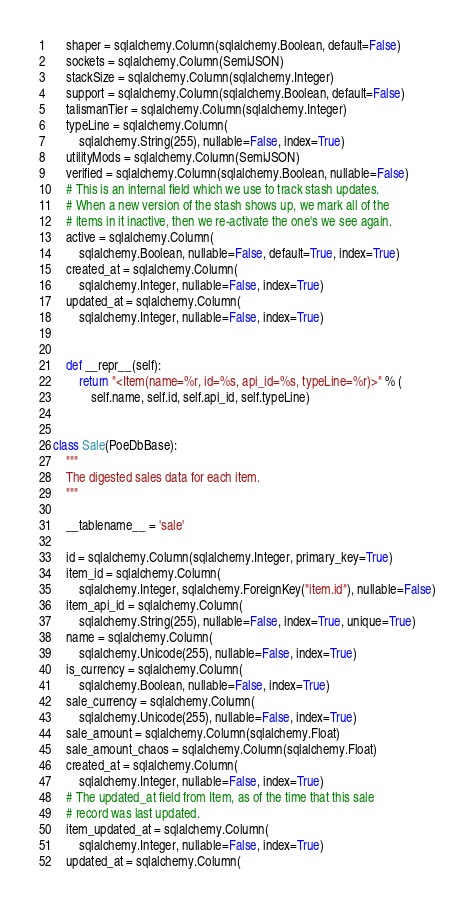Convert code to text. <code><loc_0><loc_0><loc_500><loc_500><_Python_>    shaper = sqlalchemy.Column(sqlalchemy.Boolean, default=False)
    sockets = sqlalchemy.Column(SemiJSON)
    stackSize = sqlalchemy.Column(sqlalchemy.Integer)
    support = sqlalchemy.Column(sqlalchemy.Boolean, default=False)
    talismanTier = sqlalchemy.Column(sqlalchemy.Integer)
    typeLine = sqlalchemy.Column(
        sqlalchemy.String(255), nullable=False, index=True)
    utilityMods = sqlalchemy.Column(SemiJSON)
    verified = sqlalchemy.Column(sqlalchemy.Boolean, nullable=False)
    # This is an internal field which we use to track stash updates.
    # When a new version of the stash shows up, we mark all of the
    # items in it inactive, then we re-activate the one's we see again.
    active = sqlalchemy.Column(
        sqlalchemy.Boolean, nullable=False, default=True, index=True)
    created_at = sqlalchemy.Column(
        sqlalchemy.Integer, nullable=False, index=True)
    updated_at = sqlalchemy.Column(
        sqlalchemy.Integer, nullable=False, index=True)


    def __repr__(self):
        return "<Item(name=%r, id=%s, api_id=%s, typeLine=%r)>" % (
            self.name, self.id, self.api_id, self.typeLine)


class Sale(PoeDbBase):
    """
    The digested sales data for each item.
    """

    __tablename__ = 'sale'

    id = sqlalchemy.Column(sqlalchemy.Integer, primary_key=True)
    item_id = sqlalchemy.Column(
        sqlalchemy.Integer, sqlalchemy.ForeignKey("item.id"), nullable=False)
    item_api_id = sqlalchemy.Column(
        sqlalchemy.String(255), nullable=False, index=True, unique=True)
    name = sqlalchemy.Column(
        sqlalchemy.Unicode(255), nullable=False, index=True)
    is_currency = sqlalchemy.Column(
        sqlalchemy.Boolean, nullable=False, index=True)
    sale_currency = sqlalchemy.Column(
        sqlalchemy.Unicode(255), nullable=False, index=True)
    sale_amount = sqlalchemy.Column(sqlalchemy.Float)
    sale_amount_chaos = sqlalchemy.Column(sqlalchemy.Float)
    created_at = sqlalchemy.Column(
        sqlalchemy.Integer, nullable=False, index=True)
    # The updated_at field from Item, as of the time that this sale
    # record was last updated.
    item_updated_at = sqlalchemy.Column(
        sqlalchemy.Integer, nullable=False, index=True)
    updated_at = sqlalchemy.Column(</code> 